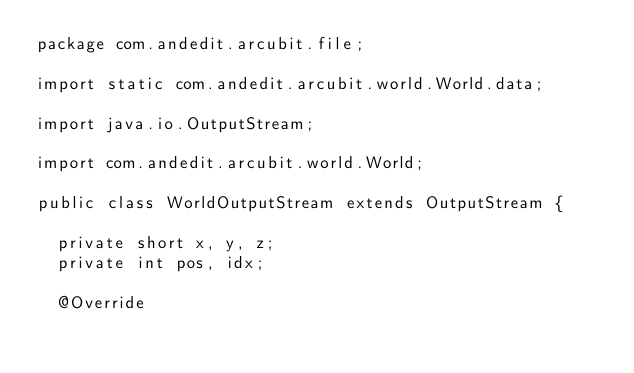Convert code to text. <code><loc_0><loc_0><loc_500><loc_500><_Java_>package com.andedit.arcubit.file;

import static com.andedit.arcubit.world.World.data;

import java.io.OutputStream;

import com.andedit.arcubit.world.World;

public class WorldOutputStream extends OutputStream {

	private short x, y, z;
	private int pos, idx;

	@Override</code> 